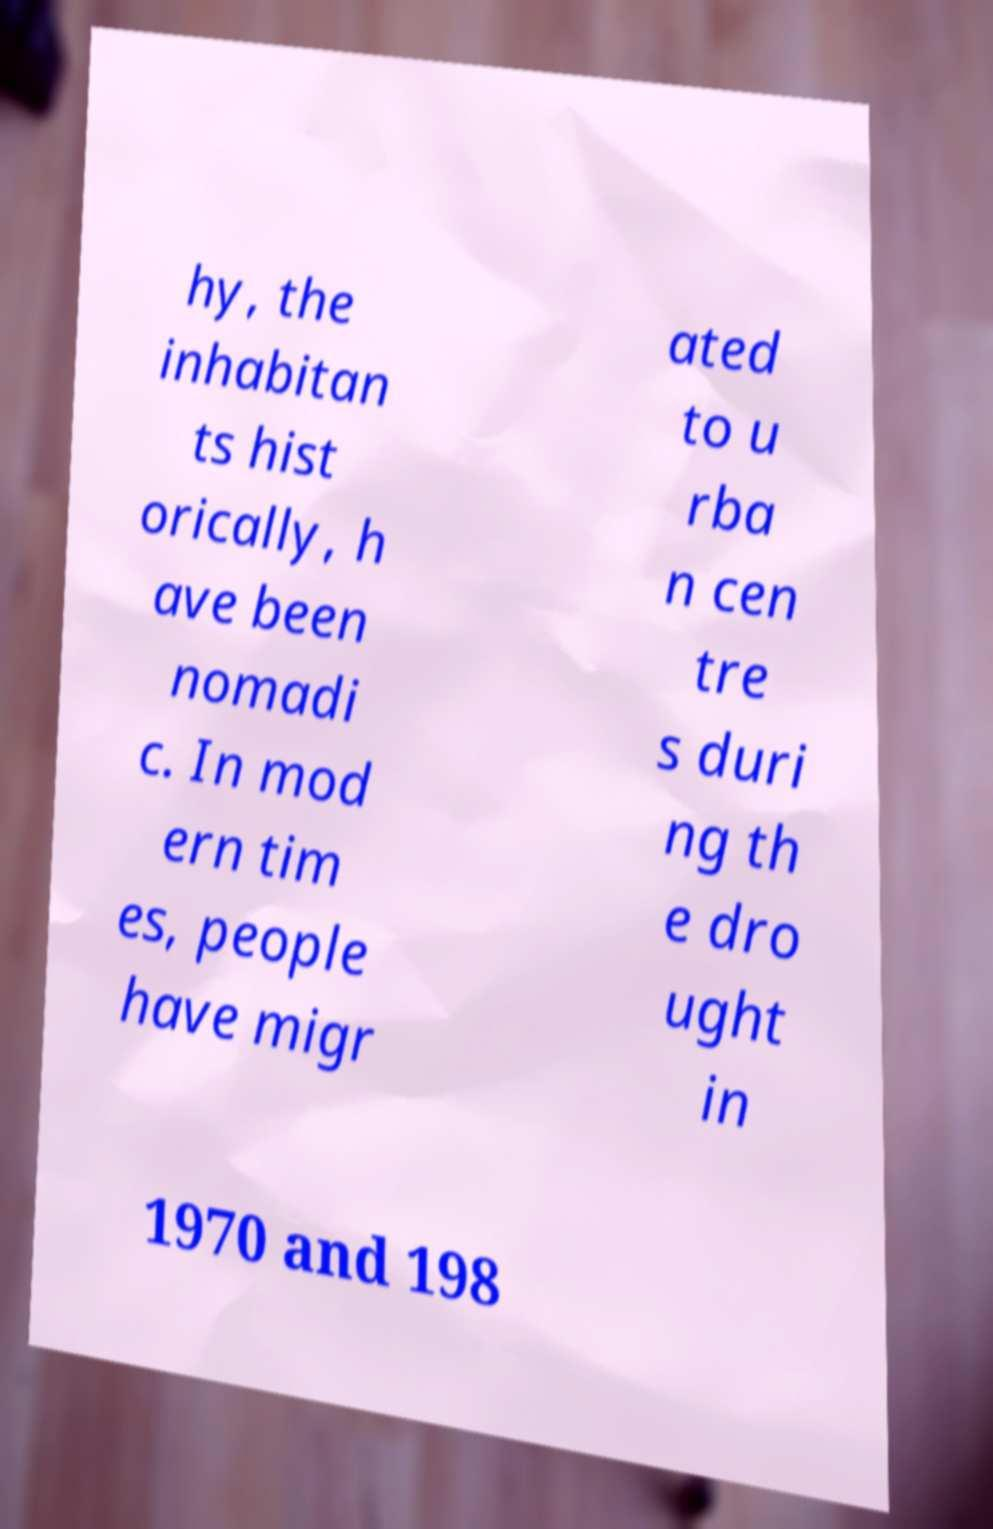Can you accurately transcribe the text from the provided image for me? hy, the inhabitan ts hist orically, h ave been nomadi c. In mod ern tim es, people have migr ated to u rba n cen tre s duri ng th e dro ught in 1970 and 198 